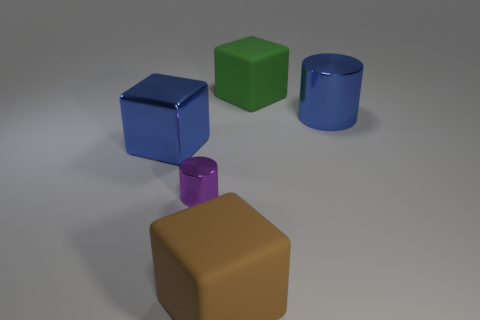There is a metallic thing that is the same color as the large metallic cube; what is its shape?
Offer a very short reply. Cylinder. What is the material of the big object in front of the cylinder to the left of the large shiny cylinder?
Provide a short and direct response. Rubber. There is a thing behind the large blue object that is behind the blue metal thing to the left of the large metal cylinder; how big is it?
Offer a very short reply. Large. Do the purple shiny cylinder and the metal cube have the same size?
Your response must be concise. No. There is a large blue metal thing in front of the large cylinder; does it have the same shape as the matte thing that is behind the brown block?
Your answer should be compact. Yes. There is a blue metallic cylinder in front of the green object; are there any big green blocks right of it?
Offer a very short reply. No. Are any small red rubber balls visible?
Your response must be concise. No. How many matte things are the same size as the blue shiny cube?
Provide a short and direct response. 2. How many objects are to the left of the large brown rubber cube and in front of the metal cube?
Your response must be concise. 1. Is the size of the cylinder on the right side of the brown block the same as the purple metal thing?
Give a very brief answer. No. 